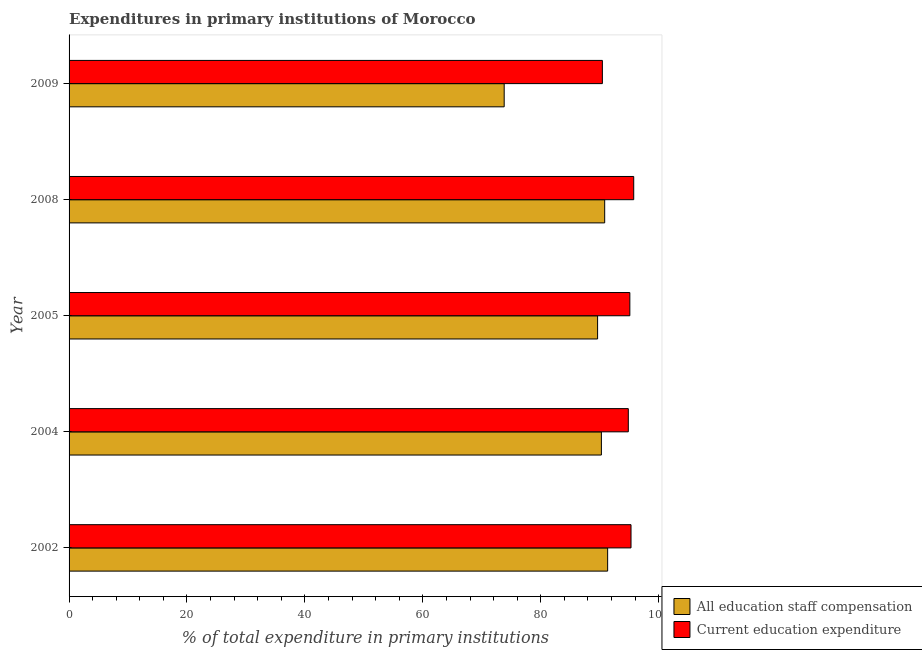How many groups of bars are there?
Provide a succinct answer. 5. Are the number of bars on each tick of the Y-axis equal?
Give a very brief answer. Yes. How many bars are there on the 3rd tick from the top?
Give a very brief answer. 2. What is the expenditure in staff compensation in 2004?
Keep it short and to the point. 90.28. Across all years, what is the maximum expenditure in education?
Keep it short and to the point. 95.77. Across all years, what is the minimum expenditure in staff compensation?
Your answer should be very brief. 73.8. In which year was the expenditure in staff compensation maximum?
Ensure brevity in your answer.  2002. In which year was the expenditure in education minimum?
Your response must be concise. 2009. What is the total expenditure in staff compensation in the graph?
Ensure brevity in your answer.  435.91. What is the difference between the expenditure in education in 2002 and that in 2005?
Ensure brevity in your answer.  0.2. What is the difference between the expenditure in staff compensation in 2002 and the expenditure in education in 2005?
Your response must be concise. -3.76. What is the average expenditure in staff compensation per year?
Provide a short and direct response. 87.18. In the year 2008, what is the difference between the expenditure in education and expenditure in staff compensation?
Keep it short and to the point. 4.92. In how many years, is the expenditure in education greater than 4 %?
Make the answer very short. 5. What is the ratio of the expenditure in education in 2002 to that in 2008?
Ensure brevity in your answer.  0.99. What is the difference between the highest and the second highest expenditure in staff compensation?
Keep it short and to the point. 0.5. What is the difference between the highest and the lowest expenditure in education?
Provide a short and direct response. 5.32. What does the 2nd bar from the top in 2005 represents?
Offer a terse response. All education staff compensation. What does the 2nd bar from the bottom in 2008 represents?
Make the answer very short. Current education expenditure. Are all the bars in the graph horizontal?
Your answer should be very brief. Yes. How many years are there in the graph?
Your response must be concise. 5. Are the values on the major ticks of X-axis written in scientific E-notation?
Your answer should be compact. No. Does the graph contain any zero values?
Offer a terse response. No. Does the graph contain grids?
Keep it short and to the point. No. Where does the legend appear in the graph?
Your answer should be very brief. Bottom right. How many legend labels are there?
Provide a short and direct response. 2. What is the title of the graph?
Your answer should be very brief. Expenditures in primary institutions of Morocco. What is the label or title of the X-axis?
Make the answer very short. % of total expenditure in primary institutions. What is the % of total expenditure in primary institutions of All education staff compensation in 2002?
Keep it short and to the point. 91.35. What is the % of total expenditure in primary institutions of Current education expenditure in 2002?
Make the answer very short. 95.31. What is the % of total expenditure in primary institutions of All education staff compensation in 2004?
Give a very brief answer. 90.28. What is the % of total expenditure in primary institutions of Current education expenditure in 2004?
Offer a terse response. 94.85. What is the % of total expenditure in primary institutions in All education staff compensation in 2005?
Make the answer very short. 89.64. What is the % of total expenditure in primary institutions of Current education expenditure in 2005?
Your answer should be very brief. 95.11. What is the % of total expenditure in primary institutions in All education staff compensation in 2008?
Your response must be concise. 90.84. What is the % of total expenditure in primary institutions in Current education expenditure in 2008?
Keep it short and to the point. 95.77. What is the % of total expenditure in primary institutions in All education staff compensation in 2009?
Your response must be concise. 73.8. What is the % of total expenditure in primary institutions of Current education expenditure in 2009?
Provide a short and direct response. 90.45. Across all years, what is the maximum % of total expenditure in primary institutions in All education staff compensation?
Keep it short and to the point. 91.35. Across all years, what is the maximum % of total expenditure in primary institutions in Current education expenditure?
Your response must be concise. 95.77. Across all years, what is the minimum % of total expenditure in primary institutions in All education staff compensation?
Make the answer very short. 73.8. Across all years, what is the minimum % of total expenditure in primary institutions in Current education expenditure?
Offer a terse response. 90.45. What is the total % of total expenditure in primary institutions in All education staff compensation in the graph?
Your response must be concise. 435.91. What is the total % of total expenditure in primary institutions in Current education expenditure in the graph?
Your answer should be compact. 471.49. What is the difference between the % of total expenditure in primary institutions of All education staff compensation in 2002 and that in 2004?
Your answer should be very brief. 1.06. What is the difference between the % of total expenditure in primary institutions in Current education expenditure in 2002 and that in 2004?
Your response must be concise. 0.46. What is the difference between the % of total expenditure in primary institutions in All education staff compensation in 2002 and that in 2005?
Offer a very short reply. 1.71. What is the difference between the % of total expenditure in primary institutions in Current education expenditure in 2002 and that in 2005?
Your answer should be very brief. 0.2. What is the difference between the % of total expenditure in primary institutions in All education staff compensation in 2002 and that in 2008?
Your answer should be compact. 0.5. What is the difference between the % of total expenditure in primary institutions in Current education expenditure in 2002 and that in 2008?
Your answer should be very brief. -0.46. What is the difference between the % of total expenditure in primary institutions of All education staff compensation in 2002 and that in 2009?
Provide a short and direct response. 17.55. What is the difference between the % of total expenditure in primary institutions in Current education expenditure in 2002 and that in 2009?
Give a very brief answer. 4.86. What is the difference between the % of total expenditure in primary institutions in All education staff compensation in 2004 and that in 2005?
Provide a succinct answer. 0.64. What is the difference between the % of total expenditure in primary institutions of Current education expenditure in 2004 and that in 2005?
Keep it short and to the point. -0.26. What is the difference between the % of total expenditure in primary institutions in All education staff compensation in 2004 and that in 2008?
Make the answer very short. -0.56. What is the difference between the % of total expenditure in primary institutions in Current education expenditure in 2004 and that in 2008?
Give a very brief answer. -0.92. What is the difference between the % of total expenditure in primary institutions of All education staff compensation in 2004 and that in 2009?
Provide a succinct answer. 16.49. What is the difference between the % of total expenditure in primary institutions in Current education expenditure in 2004 and that in 2009?
Your answer should be very brief. 4.4. What is the difference between the % of total expenditure in primary institutions in All education staff compensation in 2005 and that in 2008?
Give a very brief answer. -1.2. What is the difference between the % of total expenditure in primary institutions of Current education expenditure in 2005 and that in 2008?
Offer a terse response. -0.66. What is the difference between the % of total expenditure in primary institutions of All education staff compensation in 2005 and that in 2009?
Your answer should be compact. 15.84. What is the difference between the % of total expenditure in primary institutions of Current education expenditure in 2005 and that in 2009?
Your answer should be compact. 4.66. What is the difference between the % of total expenditure in primary institutions of All education staff compensation in 2008 and that in 2009?
Your answer should be very brief. 17.05. What is the difference between the % of total expenditure in primary institutions of Current education expenditure in 2008 and that in 2009?
Make the answer very short. 5.32. What is the difference between the % of total expenditure in primary institutions of All education staff compensation in 2002 and the % of total expenditure in primary institutions of Current education expenditure in 2004?
Your answer should be compact. -3.5. What is the difference between the % of total expenditure in primary institutions of All education staff compensation in 2002 and the % of total expenditure in primary institutions of Current education expenditure in 2005?
Your answer should be compact. -3.76. What is the difference between the % of total expenditure in primary institutions of All education staff compensation in 2002 and the % of total expenditure in primary institutions of Current education expenditure in 2008?
Give a very brief answer. -4.42. What is the difference between the % of total expenditure in primary institutions in All education staff compensation in 2002 and the % of total expenditure in primary institutions in Current education expenditure in 2009?
Your response must be concise. 0.89. What is the difference between the % of total expenditure in primary institutions in All education staff compensation in 2004 and the % of total expenditure in primary institutions in Current education expenditure in 2005?
Your answer should be very brief. -4.83. What is the difference between the % of total expenditure in primary institutions in All education staff compensation in 2004 and the % of total expenditure in primary institutions in Current education expenditure in 2008?
Provide a short and direct response. -5.48. What is the difference between the % of total expenditure in primary institutions in All education staff compensation in 2004 and the % of total expenditure in primary institutions in Current education expenditure in 2009?
Your answer should be very brief. -0.17. What is the difference between the % of total expenditure in primary institutions of All education staff compensation in 2005 and the % of total expenditure in primary institutions of Current education expenditure in 2008?
Provide a short and direct response. -6.13. What is the difference between the % of total expenditure in primary institutions in All education staff compensation in 2005 and the % of total expenditure in primary institutions in Current education expenditure in 2009?
Provide a succinct answer. -0.81. What is the difference between the % of total expenditure in primary institutions of All education staff compensation in 2008 and the % of total expenditure in primary institutions of Current education expenditure in 2009?
Keep it short and to the point. 0.39. What is the average % of total expenditure in primary institutions in All education staff compensation per year?
Give a very brief answer. 87.18. What is the average % of total expenditure in primary institutions of Current education expenditure per year?
Ensure brevity in your answer.  94.3. In the year 2002, what is the difference between the % of total expenditure in primary institutions of All education staff compensation and % of total expenditure in primary institutions of Current education expenditure?
Give a very brief answer. -3.96. In the year 2004, what is the difference between the % of total expenditure in primary institutions of All education staff compensation and % of total expenditure in primary institutions of Current education expenditure?
Offer a very short reply. -4.57. In the year 2005, what is the difference between the % of total expenditure in primary institutions in All education staff compensation and % of total expenditure in primary institutions in Current education expenditure?
Offer a very short reply. -5.47. In the year 2008, what is the difference between the % of total expenditure in primary institutions of All education staff compensation and % of total expenditure in primary institutions of Current education expenditure?
Ensure brevity in your answer.  -4.92. In the year 2009, what is the difference between the % of total expenditure in primary institutions of All education staff compensation and % of total expenditure in primary institutions of Current education expenditure?
Ensure brevity in your answer.  -16.65. What is the ratio of the % of total expenditure in primary institutions of All education staff compensation in 2002 to that in 2004?
Ensure brevity in your answer.  1.01. What is the ratio of the % of total expenditure in primary institutions in Current education expenditure in 2002 to that in 2004?
Offer a terse response. 1. What is the ratio of the % of total expenditure in primary institutions of All education staff compensation in 2002 to that in 2005?
Ensure brevity in your answer.  1.02. What is the ratio of the % of total expenditure in primary institutions of All education staff compensation in 2002 to that in 2008?
Offer a terse response. 1.01. What is the ratio of the % of total expenditure in primary institutions of All education staff compensation in 2002 to that in 2009?
Make the answer very short. 1.24. What is the ratio of the % of total expenditure in primary institutions of Current education expenditure in 2002 to that in 2009?
Ensure brevity in your answer.  1.05. What is the ratio of the % of total expenditure in primary institutions of Current education expenditure in 2004 to that in 2008?
Your answer should be very brief. 0.99. What is the ratio of the % of total expenditure in primary institutions of All education staff compensation in 2004 to that in 2009?
Your answer should be compact. 1.22. What is the ratio of the % of total expenditure in primary institutions of Current education expenditure in 2004 to that in 2009?
Your response must be concise. 1.05. What is the ratio of the % of total expenditure in primary institutions in Current education expenditure in 2005 to that in 2008?
Your response must be concise. 0.99. What is the ratio of the % of total expenditure in primary institutions of All education staff compensation in 2005 to that in 2009?
Keep it short and to the point. 1.21. What is the ratio of the % of total expenditure in primary institutions of Current education expenditure in 2005 to that in 2009?
Provide a succinct answer. 1.05. What is the ratio of the % of total expenditure in primary institutions in All education staff compensation in 2008 to that in 2009?
Provide a succinct answer. 1.23. What is the ratio of the % of total expenditure in primary institutions of Current education expenditure in 2008 to that in 2009?
Provide a succinct answer. 1.06. What is the difference between the highest and the second highest % of total expenditure in primary institutions in All education staff compensation?
Your answer should be compact. 0.5. What is the difference between the highest and the second highest % of total expenditure in primary institutions of Current education expenditure?
Your answer should be compact. 0.46. What is the difference between the highest and the lowest % of total expenditure in primary institutions in All education staff compensation?
Your answer should be compact. 17.55. What is the difference between the highest and the lowest % of total expenditure in primary institutions in Current education expenditure?
Give a very brief answer. 5.32. 